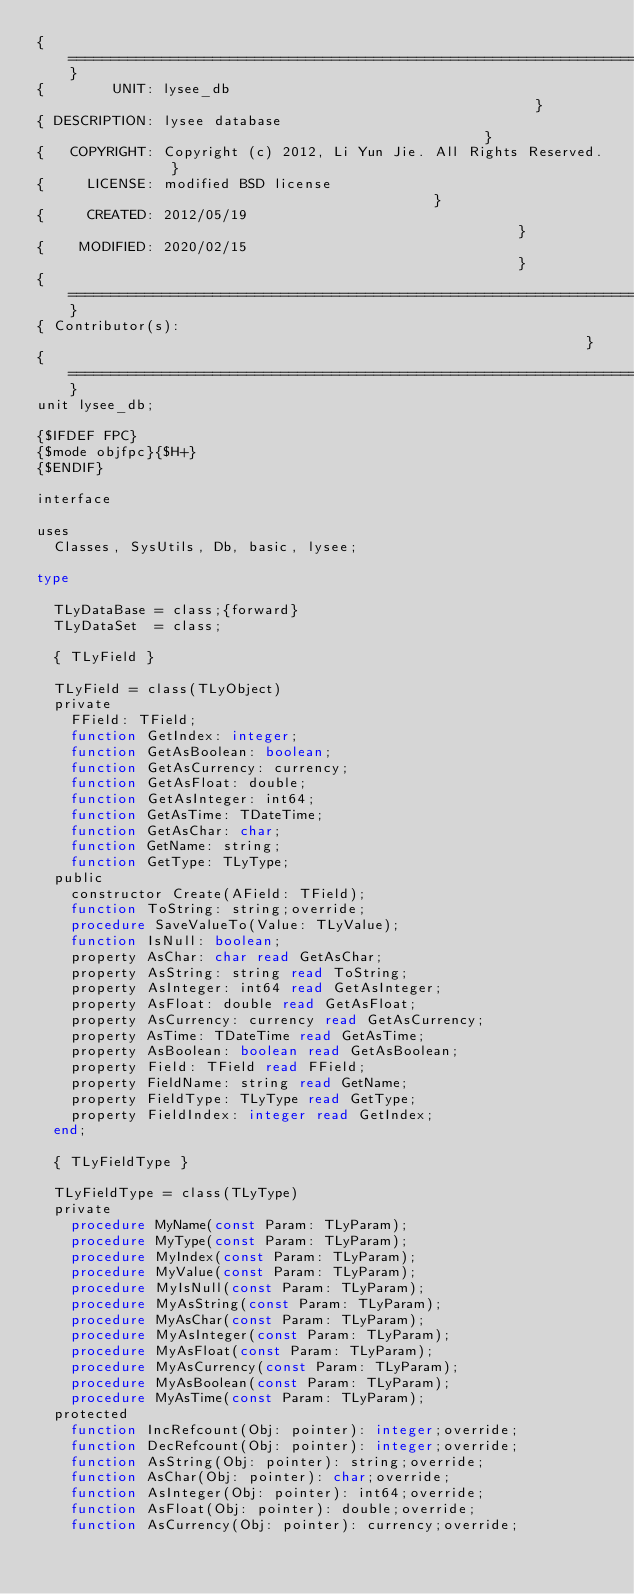<code> <loc_0><loc_0><loc_500><loc_500><_Pascal_>{==============================================================================}
{        UNIT: lysee_db                                                        }
{ DESCRIPTION: lysee database                                                  }
{   COPYRIGHT: Copyright (c) 2012, Li Yun Jie. All Rights Reserved.            }
{     LICENSE: modified BSD license                                            }
{     CREATED: 2012/05/19                                                      }
{    MODIFIED: 2020/02/15                                                      }
{==============================================================================}
{ Contributor(s):                                                              }
{==============================================================================}
unit lysee_db;

{$IFDEF FPC}
{$mode objfpc}{$H+}
{$ENDIF}

interface

uses
  Classes, SysUtils, Db, basic, lysee;

type

  TLyDataBase = class;{forward}
  TLyDataSet  = class;

  { TLyField }

  TLyField = class(TLyObject)
  private
    FField: TField;
    function GetIndex: integer;
    function GetAsBoolean: boolean;
    function GetAsCurrency: currency;
    function GetAsFloat: double;
    function GetAsInteger: int64;
    function GetAsTime: TDateTime;
    function GetAsChar: char;
    function GetName: string;
    function GetType: TLyType;
  public
    constructor Create(AField: TField);
    function ToString: string;override;
    procedure SaveValueTo(Value: TLyValue);
    function IsNull: boolean;
    property AsChar: char read GetAsChar;
    property AsString: string read ToString;
    property AsInteger: int64 read GetAsInteger;
    property AsFloat: double read GetAsFloat;
    property AsCurrency: currency read GetAsCurrency;
    property AsTime: TDateTime read GetAsTime;
    property AsBoolean: boolean read GetAsBoolean;
    property Field: TField read FField;
    property FieldName: string read GetName;
    property FieldType: TLyType read GetType;
    property FieldIndex: integer read GetIndex;
  end;

  { TLyFieldType }

  TLyFieldType = class(TLyType)
  private
    procedure MyName(const Param: TLyParam);
    procedure MyType(const Param: TLyParam);
    procedure MyIndex(const Param: TLyParam);
    procedure MyValue(const Param: TLyParam);
    procedure MyIsNull(const Param: TLyParam);
    procedure MyAsString(const Param: TLyParam);
    procedure MyAsChar(const Param: TLyParam);
    procedure MyAsInteger(const Param: TLyParam);
    procedure MyAsFloat(const Param: TLyParam);
    procedure MyAsCurrency(const Param: TLyParam);
    procedure MyAsBoolean(const Param: TLyParam);
    procedure MyAsTime(const Param: TLyParam);
  protected
    function IncRefcount(Obj: pointer): integer;override;
    function DecRefcount(Obj: pointer): integer;override;
    function AsString(Obj: pointer): string;override;
    function AsChar(Obj: pointer): char;override;
    function AsInteger(Obj: pointer): int64;override;
    function AsFloat(Obj: pointer): double;override;
    function AsCurrency(Obj: pointer): currency;override;</code> 